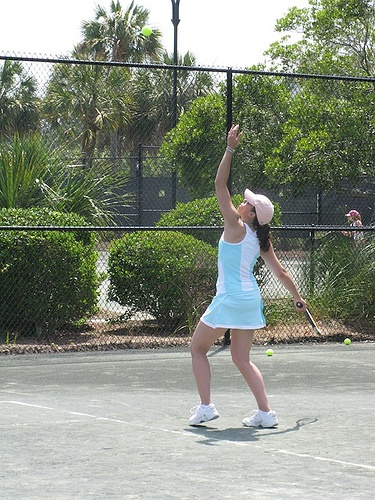Describe the objects in this image and their specific colors. I can see people in white, gray, lightblue, darkgray, and lightgray tones, people in white, black, gray, darkgreen, and darkgray tones, tennis racket in white, black, gray, ivory, and darkgray tones, tennis racket in white, gray, black, and darkgray tones, and sports ball in white, lightgreen, and ivory tones in this image. 